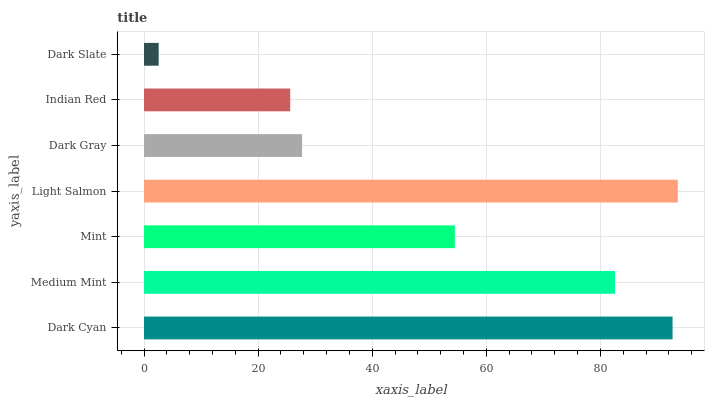Is Dark Slate the minimum?
Answer yes or no. Yes. Is Light Salmon the maximum?
Answer yes or no. Yes. Is Medium Mint the minimum?
Answer yes or no. No. Is Medium Mint the maximum?
Answer yes or no. No. Is Dark Cyan greater than Medium Mint?
Answer yes or no. Yes. Is Medium Mint less than Dark Cyan?
Answer yes or no. Yes. Is Medium Mint greater than Dark Cyan?
Answer yes or no. No. Is Dark Cyan less than Medium Mint?
Answer yes or no. No. Is Mint the high median?
Answer yes or no. Yes. Is Mint the low median?
Answer yes or no. Yes. Is Dark Cyan the high median?
Answer yes or no. No. Is Indian Red the low median?
Answer yes or no. No. 